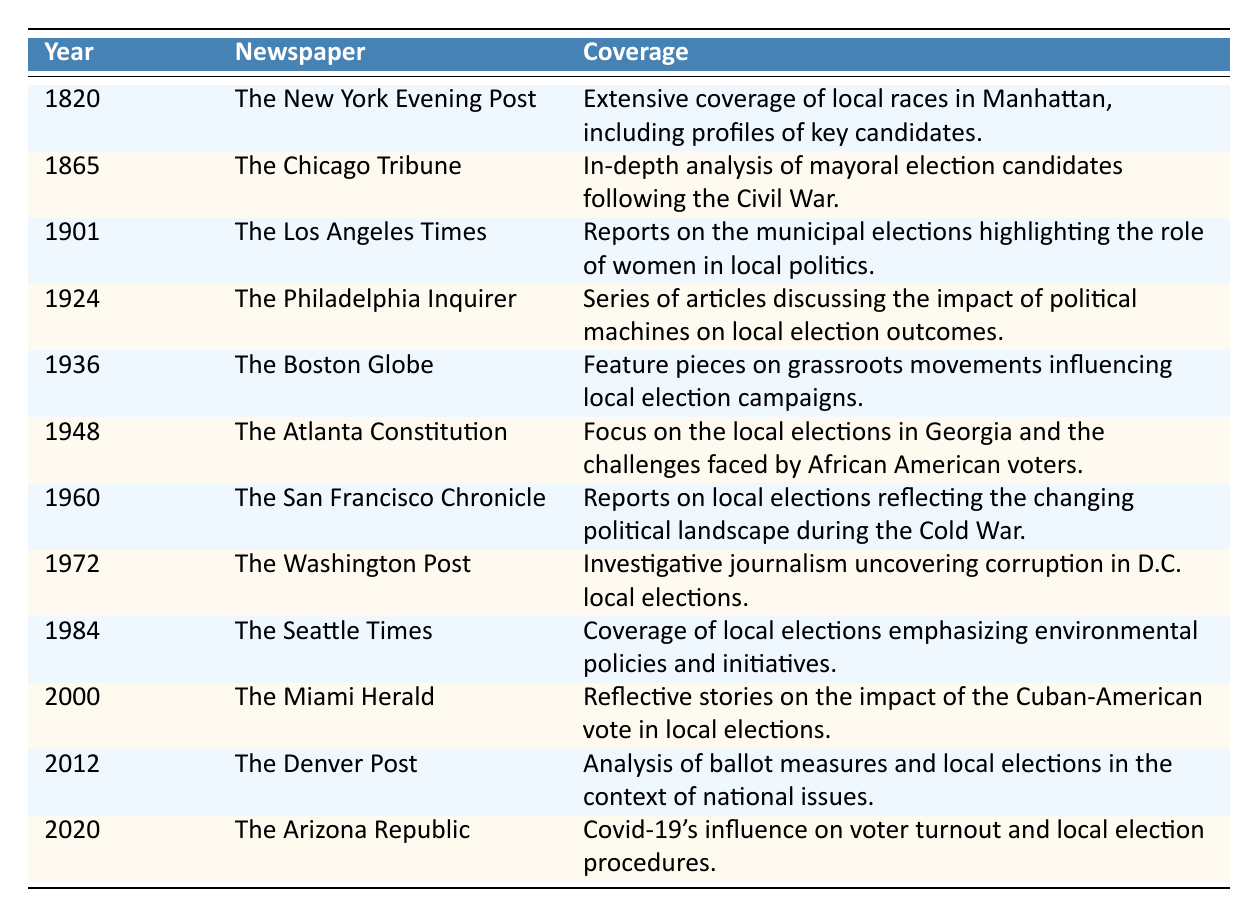What year did The Philadelphia Inquirer cover local elections? The table shows that The Philadelphia Inquirer covered local elections in the year 1924.
Answer: 1924 What topic did The Los Angeles Times address in its 1901 coverage? The Los Angeles Times in 1901 highlighted the role of women in local politics during municipal elections.
Answer: Role of women in local politics How many newspapers are listed in the table? There are a total of 11 newspapers listed for different years in the table.
Answer: 11 Did The Boston Globe cover local elections before or after 1940? The Boston Globe covered local elections in 1936, which is before 1940.
Answer: Before Which newspaper had extensive coverage of local races in Manhattan? The New York Evening Post had extensive coverage of local races in Manhattan in 1820.
Answer: The New York Evening Post What was a major theme in the coverage by The Atlanta Constitution in 1948? The major theme was the challenges faced by African American voters in the local elections in Georgia.
Answer: Challenges faced by African American voters Was there any coverage of local elections that mentioned political machines? Yes, The Philadelphia Inquirer in 1924 discussed the impact of political machines on local election outcomes.
Answer: Yes In which year did the coverage note the influence of Covid-19 on local election procedures? The Arizona Republic reported on the influence of Covid-19 on voter turnout and local election procedures in 2020.
Answer: 2020 What can be inferred about newspaper coverage of local elections over time? Over time, the coverage has increasingly focused on various social issues such as women’s roles, African American voting rights, and contemporary challenges like Covid-19.
Answer: Focus on social issues Which coverage focused on environmental policies, and in what year? The Seattle Times focused on environmental policies in the year 1984.
Answer: 1984 How many times were grassroots movements mentioned in the table regarding local elections? Grassroots movements were mentioned in The Boston Globe's coverage in 1936, indicating one instance of such mention.
Answer: 1 